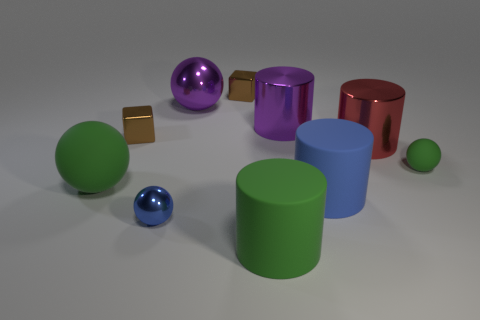Subtract all brown blocks. How many were subtracted if there are1brown blocks left? 1 Subtract all small matte spheres. How many spheres are left? 3 Subtract 2 blocks. How many blocks are left? 0 Subtract all purple balls. How many balls are left? 3 Subtract all brown spheres. How many blue cylinders are left? 1 Subtract all large cylinders. Subtract all blue rubber spheres. How many objects are left? 6 Add 7 large metallic things. How many large metallic things are left? 10 Add 3 big blue metallic cylinders. How many big blue metallic cylinders exist? 3 Subtract 0 yellow cubes. How many objects are left? 10 Subtract all blocks. How many objects are left? 8 